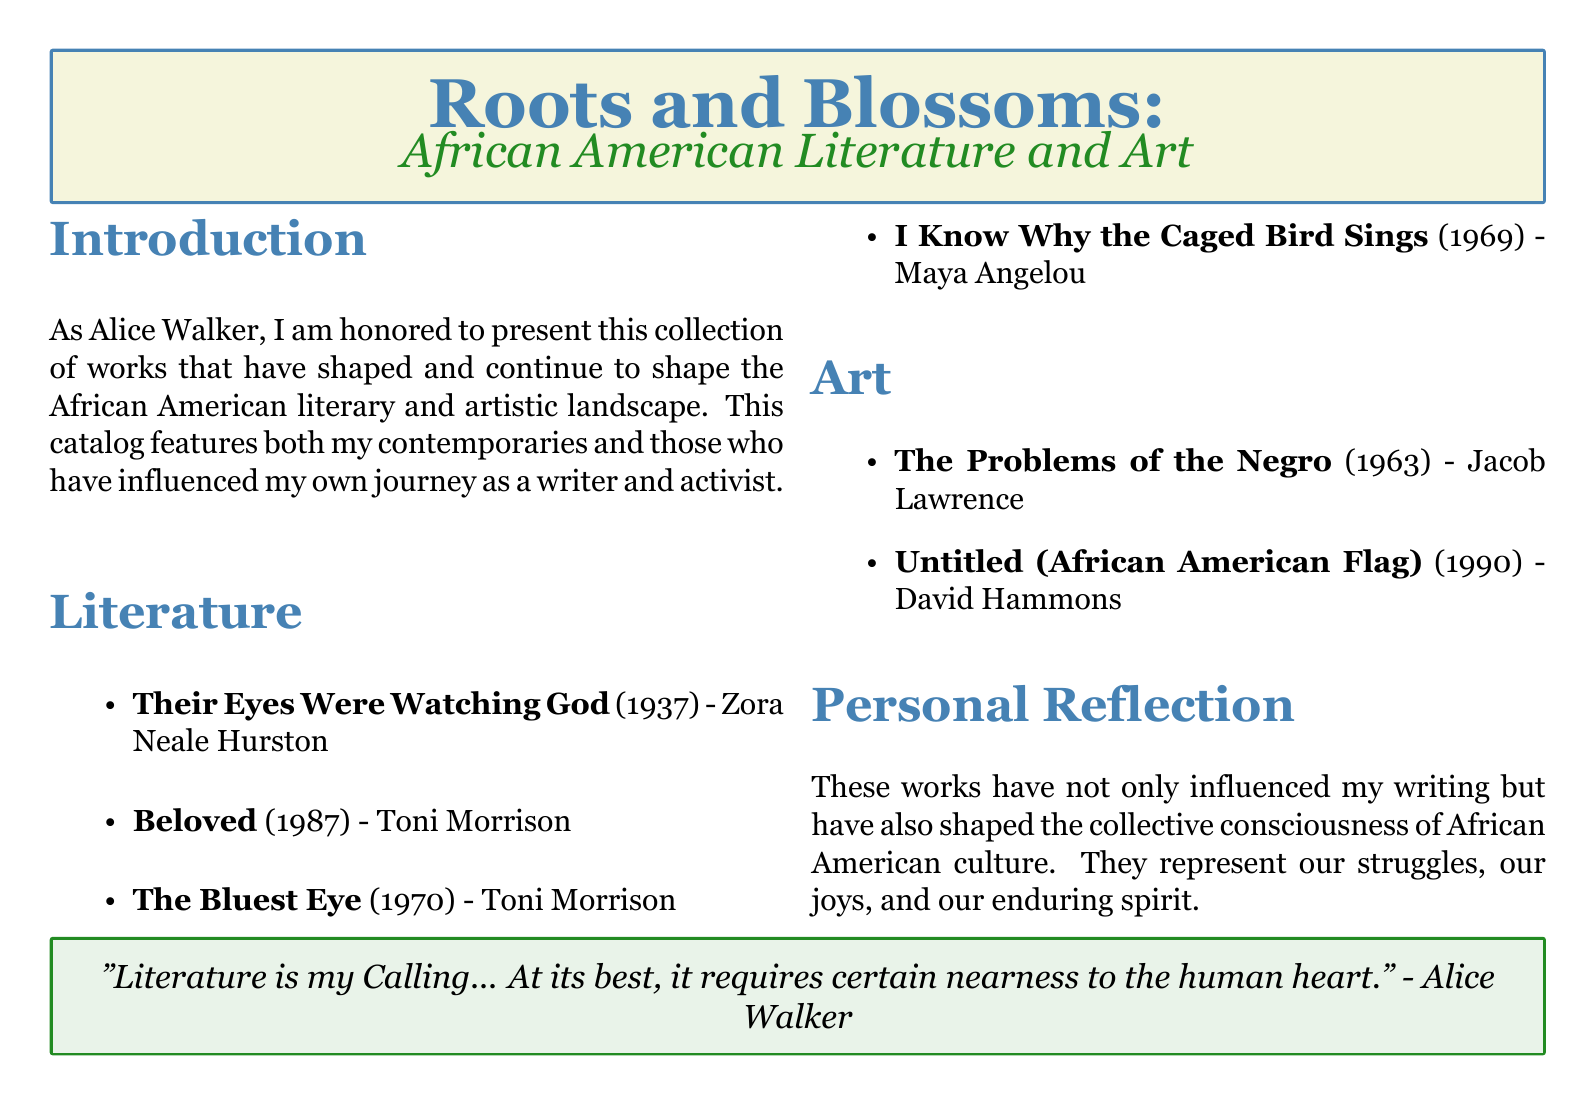What is the title of the catalog? The title is prominently displayed at the top of the document, highlighting the theme of the collection.
Answer: Roots and Blossoms Who wrote "Their Eyes Were Watching God"? This is the name of the author listed in the literature section of the catalog.
Answer: Zora Neale Hurston What year was "Beloved" published? The year is specified next to the title in the literature section of the catalog.
Answer: 1987 Which artist created "Untitled (African American Flag)"? The artist's name is mentioned in the art section alongside the title of the artwork.
Answer: David Hammons What does Alice Walker reflect on in the personal reflection section? This reflects the main themes and influence of the works listed in the catalog.
Answer: Collective consciousness How many literary works are mentioned in the catalog? The total count of items listed in the literature section can be derived by counting them.
Answer: 4 What color is used for the background of the personal reflection box? This can be observed directly in the layout of the document.
Answer: My green What is Alice Walker's opinion on literature as expressed in the quote? The quote summarizes her sentiment about literature and its emotional connection.
Answer: Calling 